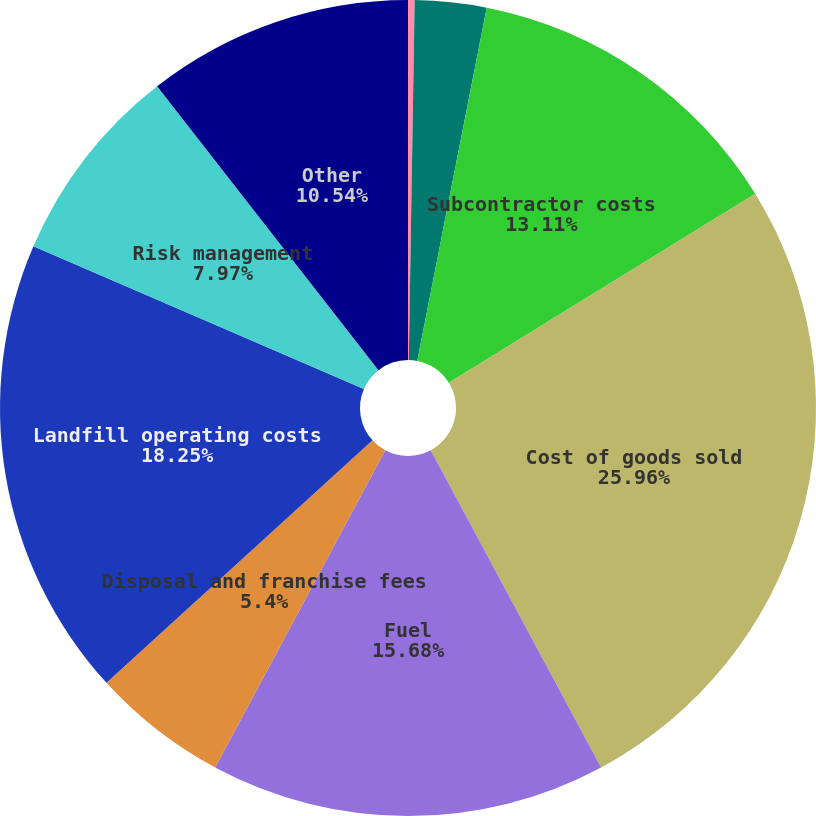Convert chart. <chart><loc_0><loc_0><loc_500><loc_500><pie_chart><fcel>Transfer and disposal costs<fcel>Maintenance and repairs<fcel>Subcontractor costs<fcel>Cost of goods sold<fcel>Fuel<fcel>Disposal and franchise fees<fcel>Landfill operating costs<fcel>Risk management<fcel>Other<nl><fcel>0.26%<fcel>2.83%<fcel>13.11%<fcel>25.95%<fcel>15.68%<fcel>5.4%<fcel>18.25%<fcel>7.97%<fcel>10.54%<nl></chart> 